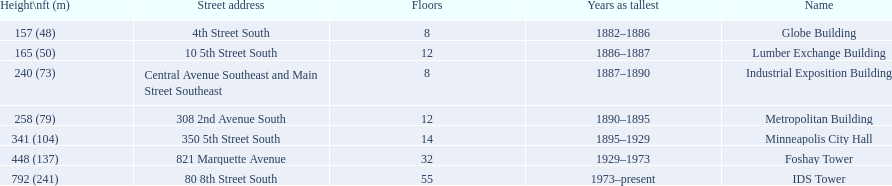How tall is the metropolitan building? 258 (79). How tall is the lumber exchange building? 165 (50). Is the metropolitan or lumber exchange building taller? Metropolitan Building. 